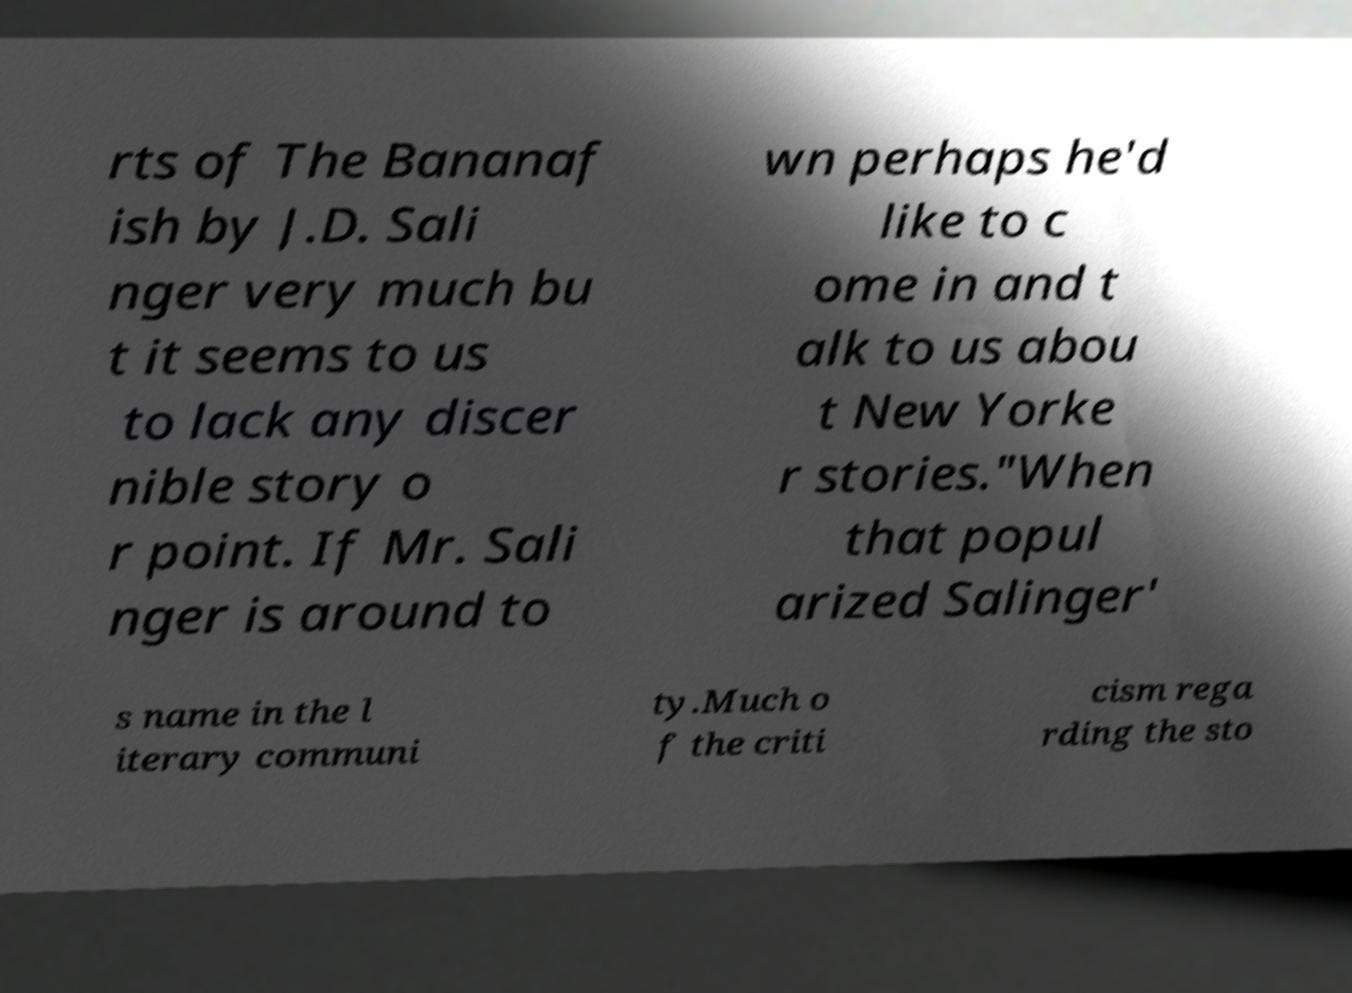Can you read and provide the text displayed in the image?This photo seems to have some interesting text. Can you extract and type it out for me? rts of The Bananaf ish by J.D. Sali nger very much bu t it seems to us to lack any discer nible story o r point. If Mr. Sali nger is around to wn perhaps he'd like to c ome in and t alk to us abou t New Yorke r stories."When that popul arized Salinger' s name in the l iterary communi ty.Much o f the criti cism rega rding the sto 